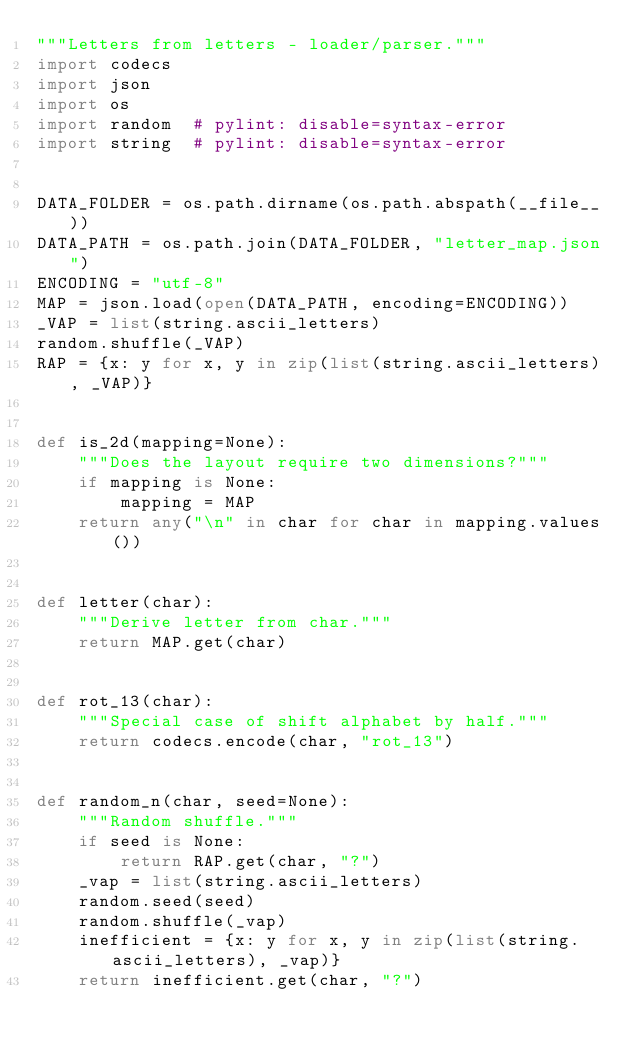<code> <loc_0><loc_0><loc_500><loc_500><_Python_>"""Letters from letters - loader/parser."""
import codecs
import json
import os
import random  # pylint: disable=syntax-error
import string  # pylint: disable=syntax-error


DATA_FOLDER = os.path.dirname(os.path.abspath(__file__))
DATA_PATH = os.path.join(DATA_FOLDER, "letter_map.json")
ENCODING = "utf-8"
MAP = json.load(open(DATA_PATH, encoding=ENCODING))
_VAP = list(string.ascii_letters)
random.shuffle(_VAP)
RAP = {x: y for x, y in zip(list(string.ascii_letters), _VAP)}


def is_2d(mapping=None):
    """Does the layout require two dimensions?"""
    if mapping is None:
        mapping = MAP
    return any("\n" in char for char in mapping.values())


def letter(char):
    """Derive letter from char."""
    return MAP.get(char)


def rot_13(char):
    """Special case of shift alphabet by half."""
    return codecs.encode(char, "rot_13")


def random_n(char, seed=None):
    """Random shuffle."""
    if seed is None:
        return RAP.get(char, "?")
    _vap = list(string.ascii_letters)
    random.seed(seed)
    random.shuffle(_vap)
    inefficient = {x: y for x, y in zip(list(string.ascii_letters), _vap)}
    return inefficient.get(char, "?")
</code> 